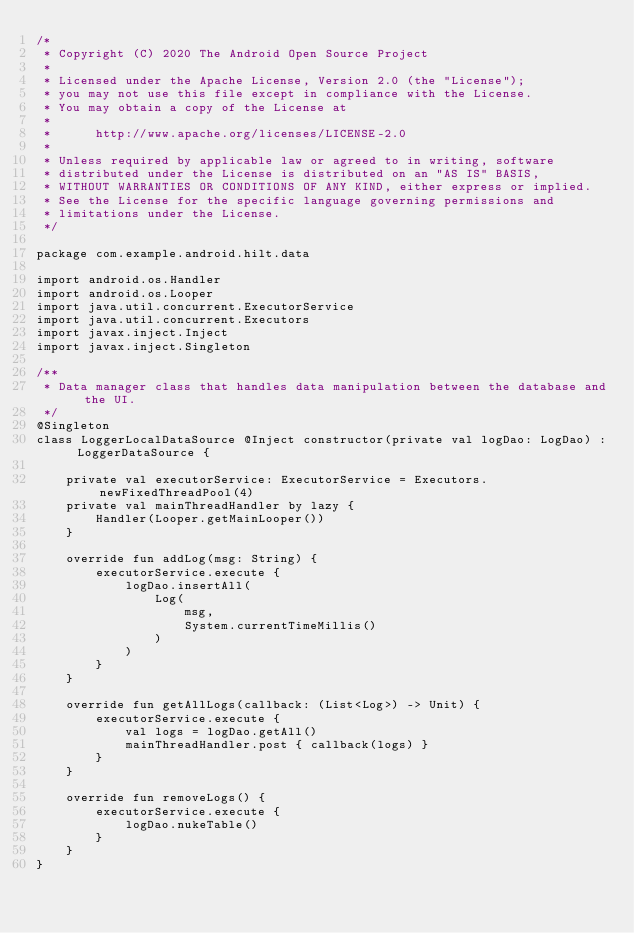<code> <loc_0><loc_0><loc_500><loc_500><_Kotlin_>/*
 * Copyright (C) 2020 The Android Open Source Project
 *
 * Licensed under the Apache License, Version 2.0 (the "License");
 * you may not use this file except in compliance with the License.
 * You may obtain a copy of the License at
 *
 *      http://www.apache.org/licenses/LICENSE-2.0
 *
 * Unless required by applicable law or agreed to in writing, software
 * distributed under the License is distributed on an "AS IS" BASIS,
 * WITHOUT WARRANTIES OR CONDITIONS OF ANY KIND, either express or implied.
 * See the License for the specific language governing permissions and
 * limitations under the License.
 */

package com.example.android.hilt.data

import android.os.Handler
import android.os.Looper
import java.util.concurrent.ExecutorService
import java.util.concurrent.Executors
import javax.inject.Inject
import javax.inject.Singleton

/**
 * Data manager class that handles data manipulation between the database and the UI.
 */
@Singleton
class LoggerLocalDataSource @Inject constructor(private val logDao: LogDao) : LoggerDataSource {

    private val executorService: ExecutorService = Executors.newFixedThreadPool(4)
    private val mainThreadHandler by lazy {
        Handler(Looper.getMainLooper())
    }

    override fun addLog(msg: String) {
        executorService.execute {
            logDao.insertAll(
                Log(
                    msg,
                    System.currentTimeMillis()
                )
            )
        }
    }

    override fun getAllLogs(callback: (List<Log>) -> Unit) {
        executorService.execute {
            val logs = logDao.getAll()
            mainThreadHandler.post { callback(logs) }
        }
    }

    override fun removeLogs() {
        executorService.execute {
            logDao.nukeTable()
        }
    }
}
</code> 